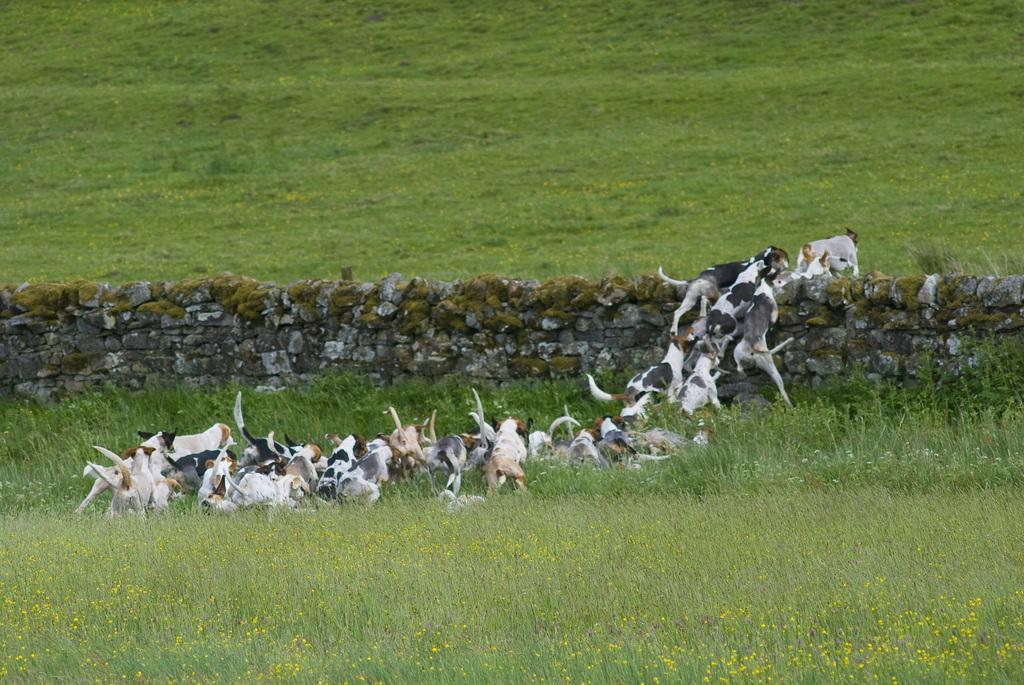What animals can be seen in the image? There are dogs in the image. What are the dogs doing in the image? The dogs are running on the ground and jumping from the wall. What is the surface of the ground covered with? The ground is covered with dry plants. What type of wall is present in the image? There is a wall made up of stones in the image. What degree does the governor hold, as seen in the image? There is no mention of a governor or any degrees in the image; it features dogs running and jumping on the ground and a stone wall. 